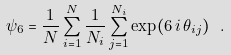<formula> <loc_0><loc_0><loc_500><loc_500>\psi _ { 6 } = \frac { 1 } { N } \sum _ { i = 1 } ^ { N } \frac { 1 } { N _ { i } } \sum _ { j = 1 } ^ { N _ { i } } \exp ( 6 \, { i } \, \theta _ { i j } ) \ .</formula> 